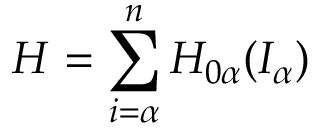Convert formula to latex. <formula><loc_0><loc_0><loc_500><loc_500>H = \sum _ { i = \alpha } ^ { n } H _ { 0 \alpha } ( I _ { \alpha } )</formula> 